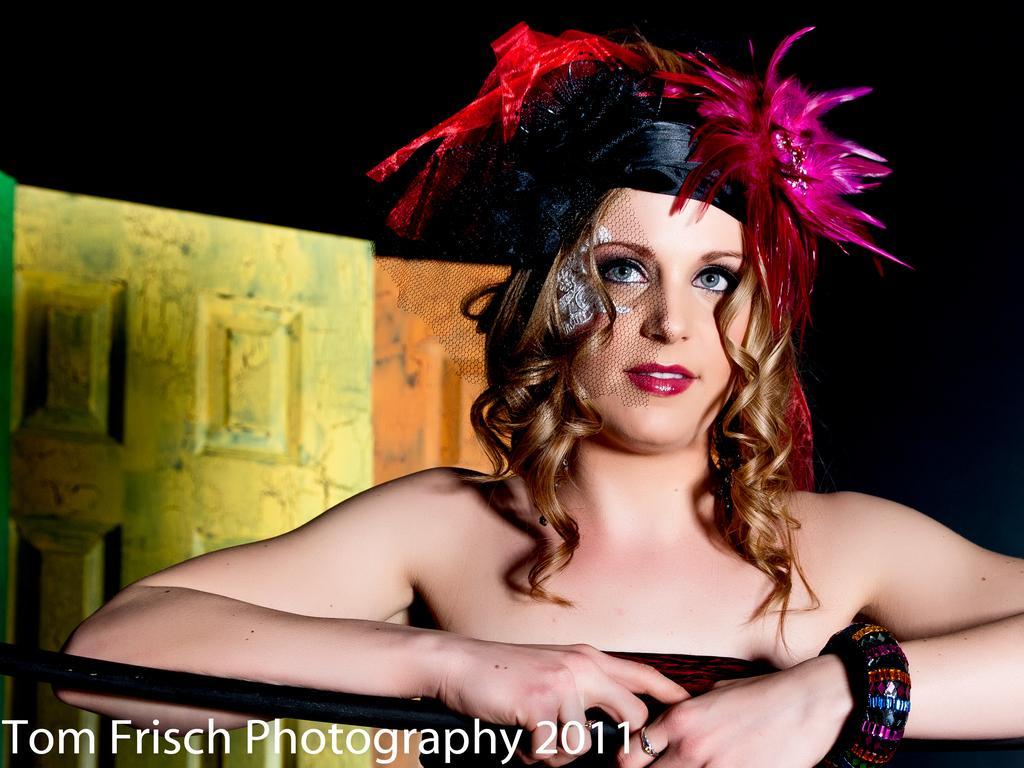Could you give a brief overview of what you see in this image? In this image in the foreground there is one woman who is wearing a headband, and in the background there are some objects. And at the bottom of the image there is text, and there is black background. 